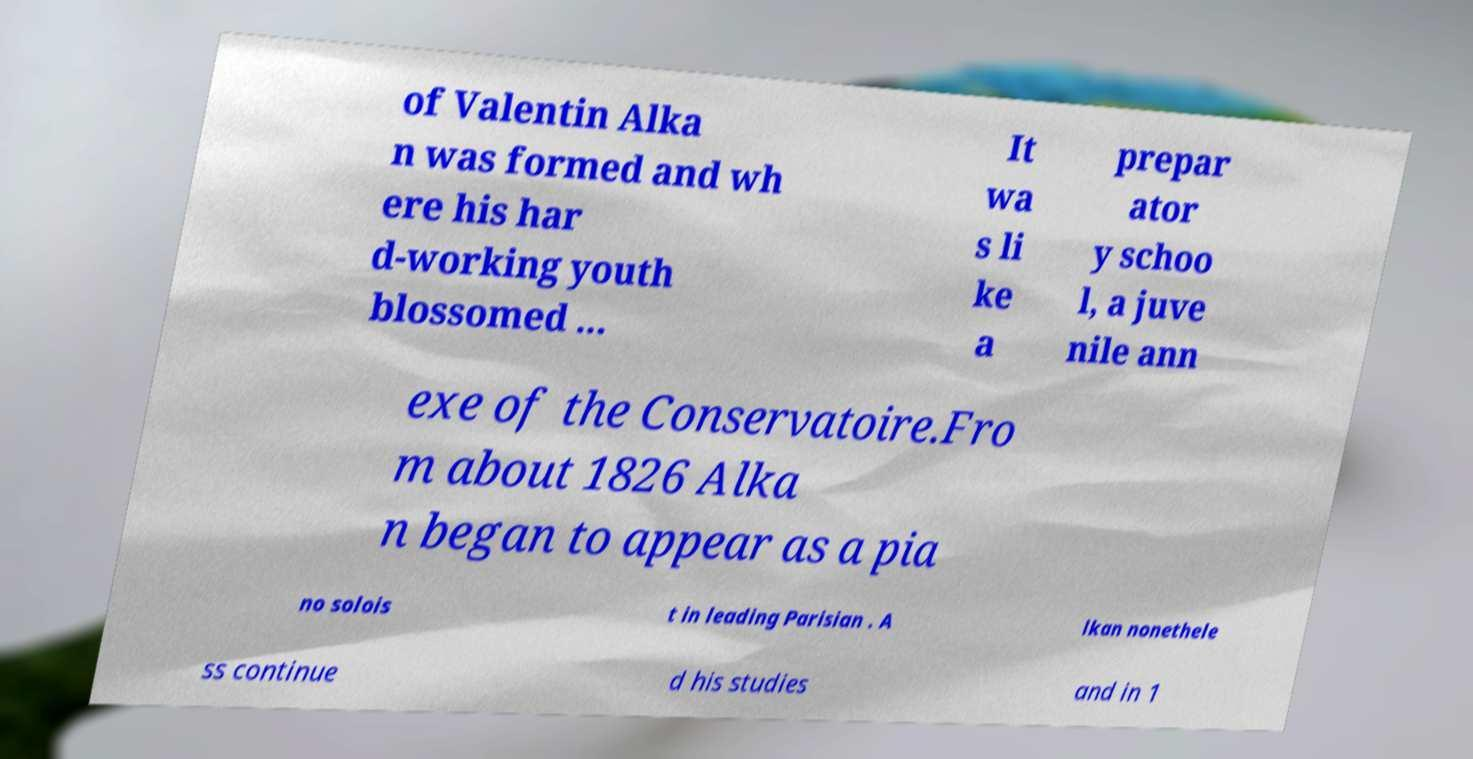There's text embedded in this image that I need extracted. Can you transcribe it verbatim? of Valentin Alka n was formed and wh ere his har d-working youth blossomed ... It wa s li ke a prepar ator y schoo l, a juve nile ann exe of the Conservatoire.Fro m about 1826 Alka n began to appear as a pia no solois t in leading Parisian . A lkan nonethele ss continue d his studies and in 1 